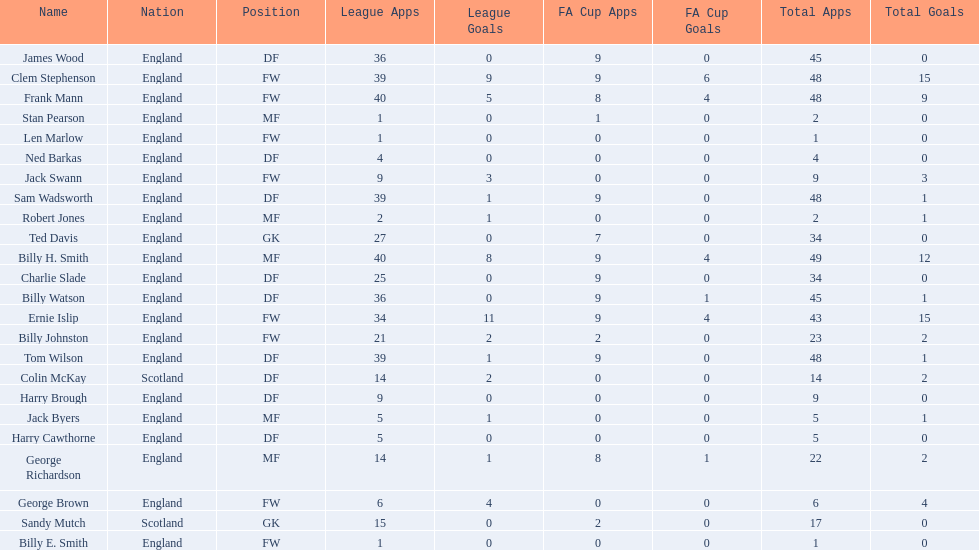Average number of goals scored by players from scotland 1. 